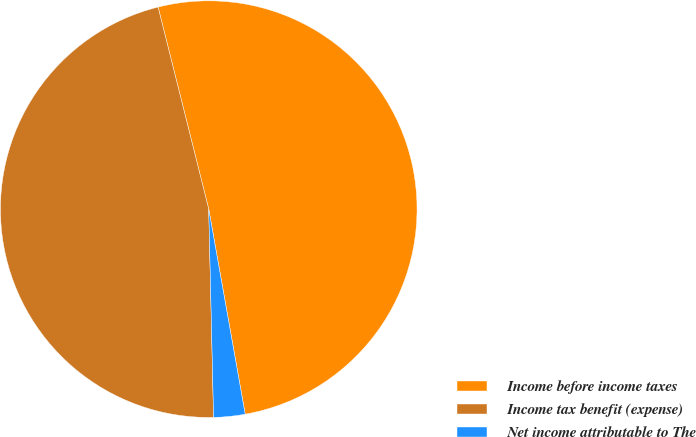<chart> <loc_0><loc_0><loc_500><loc_500><pie_chart><fcel>Income before income taxes<fcel>Income tax benefit (expense)<fcel>Net income attributable to The<nl><fcel>51.11%<fcel>46.46%<fcel>2.43%<nl></chart> 